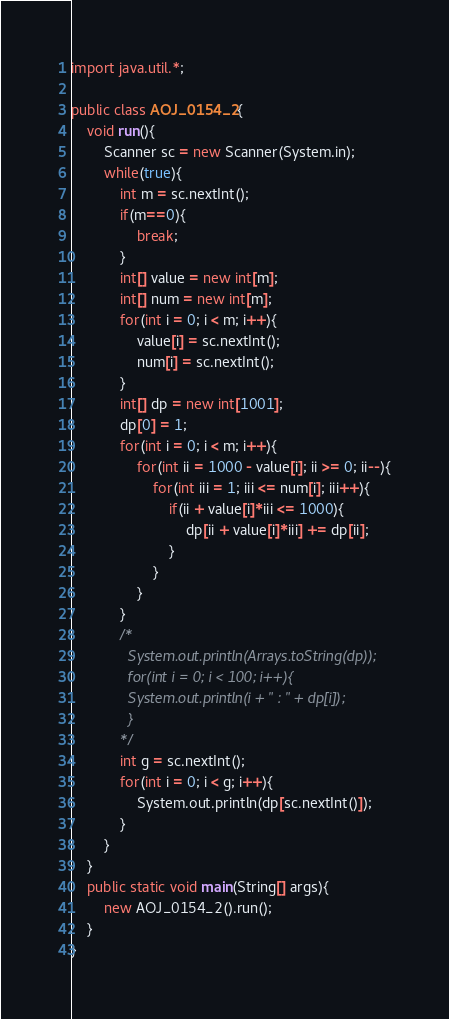Convert code to text. <code><loc_0><loc_0><loc_500><loc_500><_Java_>import java.util.*;

public class AOJ_0154_2{
    void run(){
        Scanner sc = new Scanner(System.in);
        while(true){
            int m = sc.nextInt();
            if(m==0){
                break;
            }
            int[] value = new int[m];
            int[] num = new int[m];
            for(int i = 0; i < m; i++){
                value[i] = sc.nextInt();
                num[i] = sc.nextInt();
            }
            int[] dp = new int[1001];
            dp[0] = 1;
            for(int i = 0; i < m; i++){
                for(int ii = 1000 - value[i]; ii >= 0; ii--){
                    for(int iii = 1; iii <= num[i]; iii++){
                        if(ii + value[i]*iii <= 1000){
                            dp[ii + value[i]*iii] += dp[ii];
                        }
                    }
                }
            }
            /*
              System.out.println(Arrays.toString(dp));
              for(int i = 0; i < 100; i++){
              System.out.println(i + " : " + dp[i]);
              }
            */
            int g = sc.nextInt();
            for(int i = 0; i < g; i++){
                System.out.println(dp[sc.nextInt()]);
            }
        }
    }
    public static void main(String[] args){
        new AOJ_0154_2().run();
    }
}</code> 